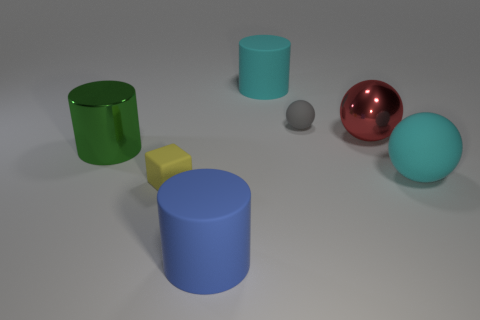Are there any other things that have the same shape as the small yellow object?
Your answer should be very brief. No. Is the shape of the big green thing the same as the small gray rubber thing?
Provide a succinct answer. No. How big is the red ball?
Provide a succinct answer. Large. What color is the big cylinder that is both in front of the red metallic object and on the right side of the cube?
Your response must be concise. Blue. Are there more large cyan objects than metal cylinders?
Offer a terse response. Yes. What number of objects are either large objects or rubber things on the right side of the metallic ball?
Provide a succinct answer. 5. Does the cyan matte sphere have the same size as the green metal object?
Give a very brief answer. Yes. There is a tiny yellow rubber object; are there any metallic objects in front of it?
Provide a succinct answer. No. What is the size of the thing that is both in front of the cyan matte sphere and on the left side of the blue cylinder?
Offer a very short reply. Small. What number of objects are tiny objects or big brown rubber cylinders?
Your answer should be compact. 2. 